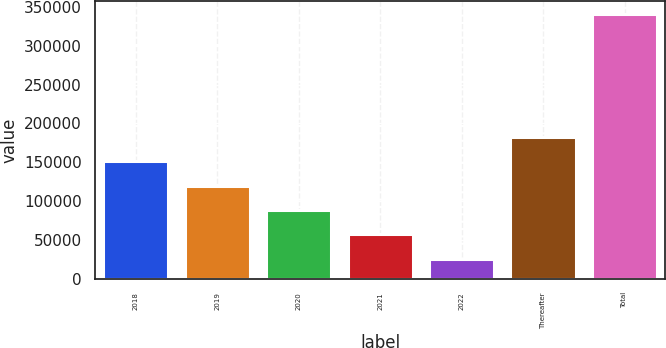Convert chart to OTSL. <chart><loc_0><loc_0><loc_500><loc_500><bar_chart><fcel>2018<fcel>2019<fcel>2020<fcel>2021<fcel>2022<fcel>Thereafter<fcel>Total<nl><fcel>151719<fcel>120229<fcel>88738.2<fcel>57247.6<fcel>25757<fcel>183210<fcel>340663<nl></chart> 